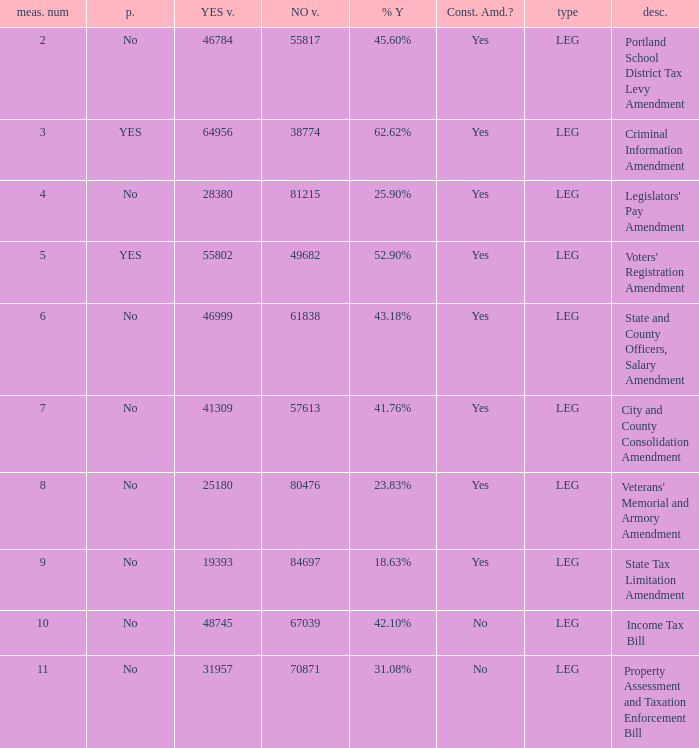HOw many no votes were there when there were 45.60% yes votes 55817.0. 